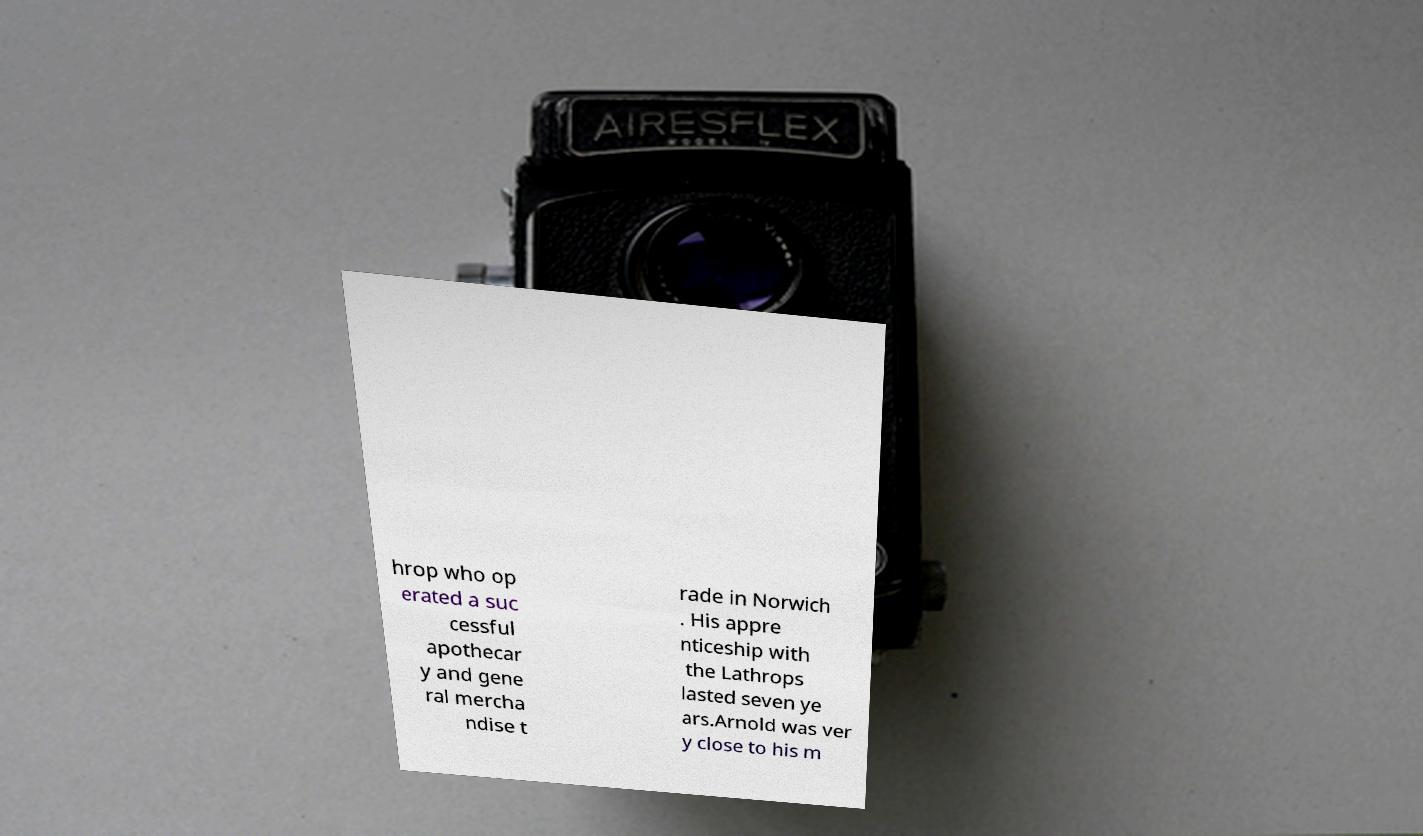For documentation purposes, I need the text within this image transcribed. Could you provide that? hrop who op erated a suc cessful apothecar y and gene ral mercha ndise t rade in Norwich . His appre nticeship with the Lathrops lasted seven ye ars.Arnold was ver y close to his m 